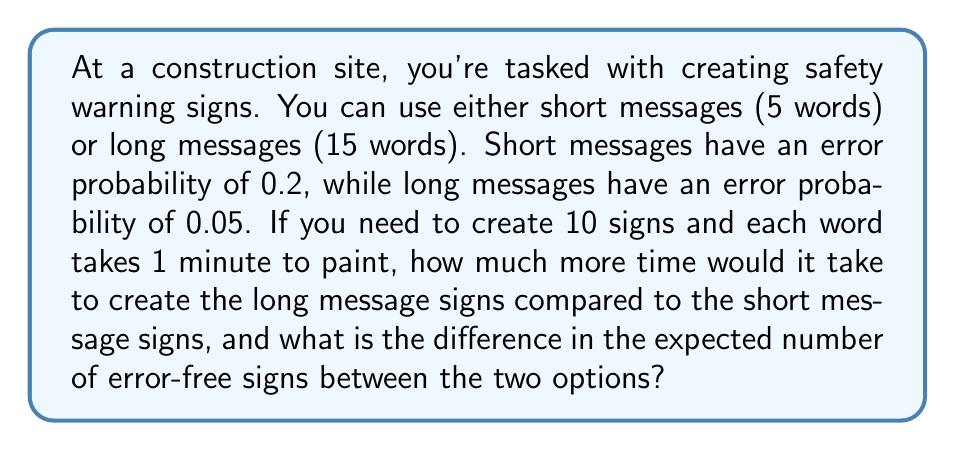Give your solution to this math problem. Let's break this down step-by-step:

1. Time calculation:
   - Short messages: 5 words × 1 minute/word × 10 signs = 50 minutes
   - Long messages: 15 words × 1 minute/word × 10 signs = 150 minutes
   - Time difference: 150 - 50 = 100 minutes

2. Error-free probability calculation:
   - Short messages: 1 - 0.2 = 0.8 probability of being error-free
   - Long messages: 1 - 0.05 = 0.95 probability of being error-free

3. Expected number of error-free signs:
   - Short messages: 0.8 × 10 signs = 8 error-free signs
   - Long messages: 0.95 × 10 signs = 9.5 error-free signs

4. Difference in expected error-free signs:
   9.5 - 8 = 1.5 signs

To calculate the trade-off, we can use the concept of information rate from information theory:

$$R = \frac{I}{T}$$

Where $R$ is the information rate, $I$ is the information transmitted, and $T$ is the time taken.

For short messages:
$$R_s = \frac{8 \text{ error-free signs}}{50 \text{ minutes}} = 0.16 \text{ signs/minute}$$

For long messages:
$$R_l = \frac{9.5 \text{ error-free signs}}{150 \text{ minutes}} = 0.0633 \text{ signs/minute}$$

The trade-off shows that while long messages take more time, they have a higher probability of being error-free. However, the information rate is lower for long messages, indicating that short messages are more efficient in terms of time vs. error-free signs produced.
Answer: It would take 100 minutes more to create the long message signs, and there would be 1.5 more expected error-free signs with the long messages compared to the short messages. 